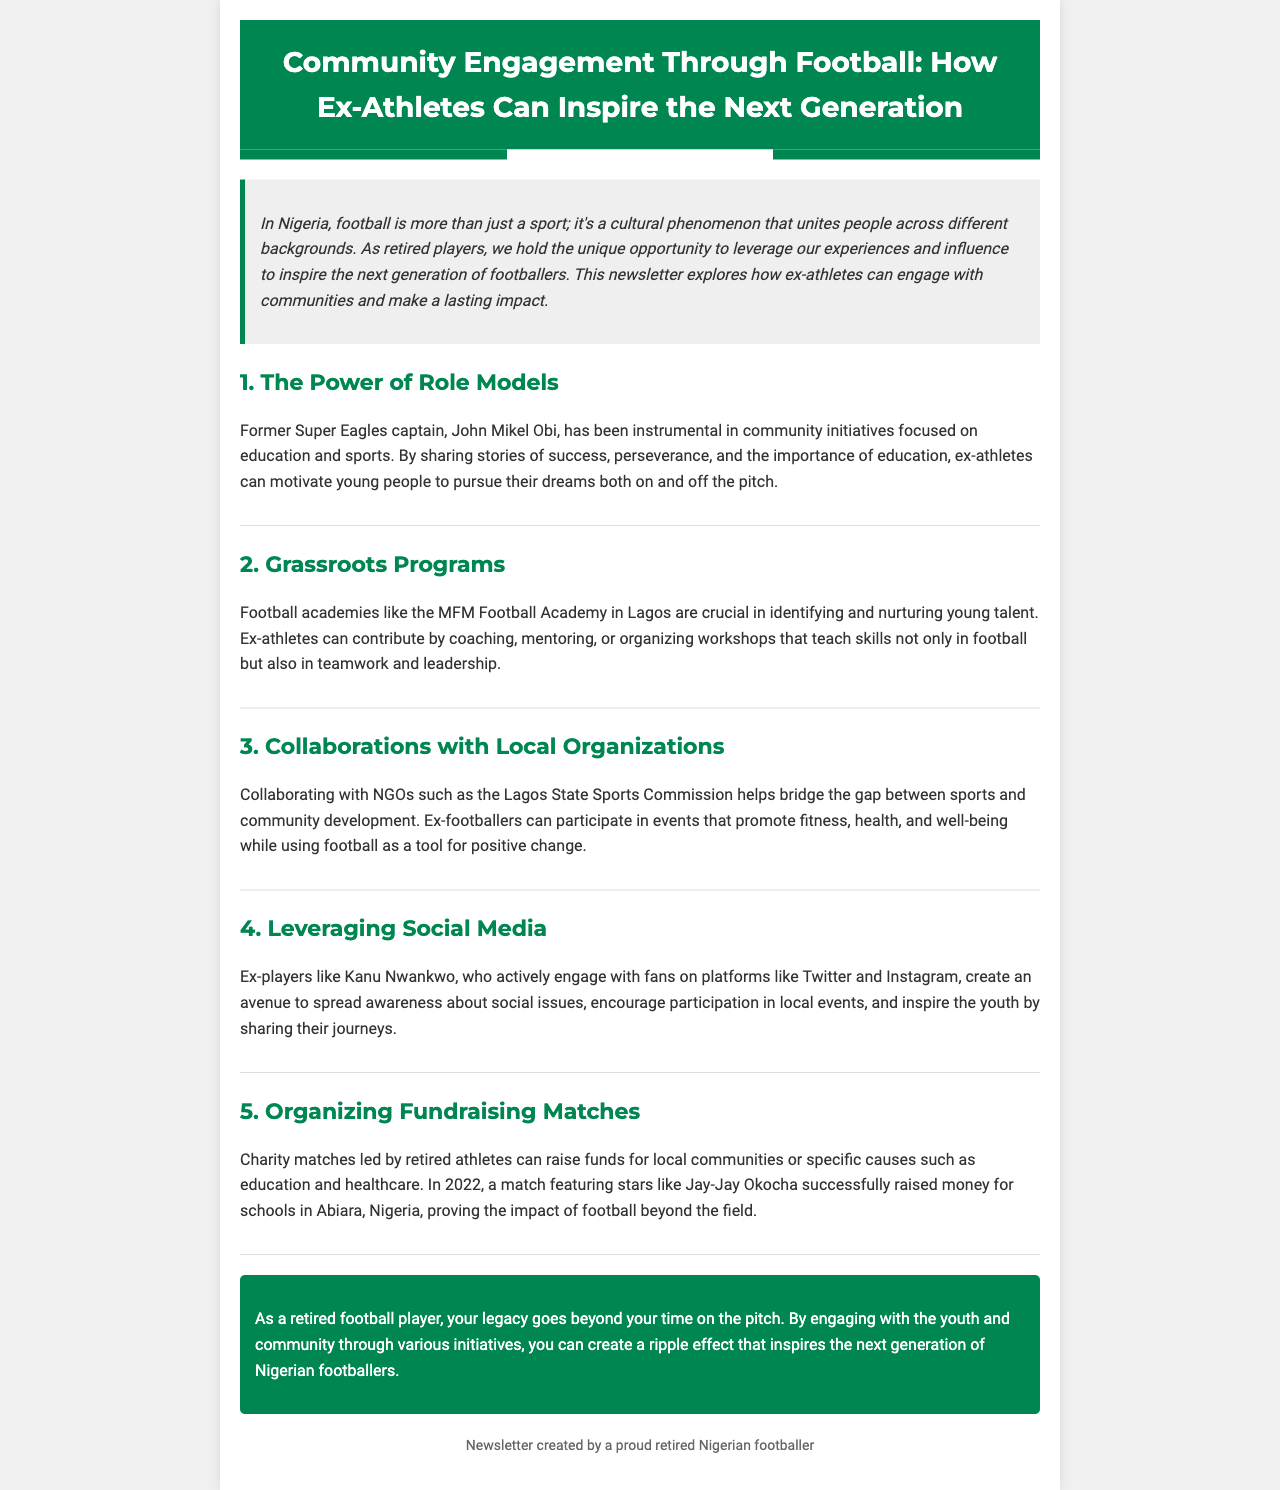What is the title of the newsletter? The title of the newsletter is presented in the header of the document.
Answer: Community Engagement Through Football: How Ex-Athletes Can Inspire the Next Generation Who is mentioned as a former Super Eagles captain? The document specifies John Mikel Obi as a prominent figure in community initiatives.
Answer: John Mikel Obi What is the name of the football academy mentioned in Lagos? The document refers to the MFM Football Academy as a significant institution for nurturing talent.
Answer: MFM Football Academy What year did a charity match featuring Jay-Jay Okocha take place? The newsletter mentions the year associated with the charity match as a key event.
Answer: 2022 What is one way ex-athletes can engage with youth according to the document? The newsletter suggests several ways ex-athletes can inspire young people, focusing on specific activities.
Answer: Coaching How do ex-players utilize social media according to the newsletter? The document outlines the use of social media by ex-players to spread awareness and inspire youth.
Answer: To engage fans What is a key benefit of organizing fundraising matches? The newsletter describes the fundraising matches as beneficial for specific causes.
Answer: Raise funds What is the main focus of the newsletter? The focus is outlined within the introductory text, summarizing the document's theme.
Answer: Community engagement through football What is highlighted as a ripple effect created by retired players? The conclusion points to a positive outcome of engaging with communities and youth.
Answer: Inspire the next generation of Nigerian footballers 